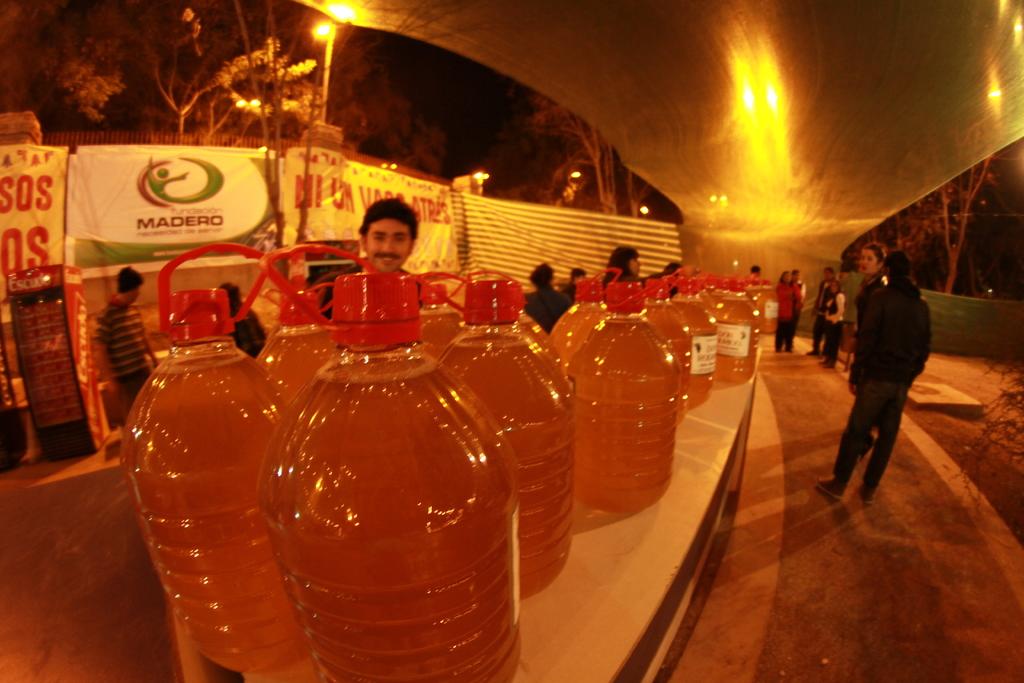What is on the green and white sign in the background?
Offer a very short reply. Madero. 